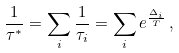Convert formula to latex. <formula><loc_0><loc_0><loc_500><loc_500>\frac { 1 } { \tau ^ { * } } = \sum _ { i } \frac { 1 } { \tau _ { i } } = \sum _ { i } e ^ { \frac { \Delta _ { i } } { T } } \, ,</formula> 